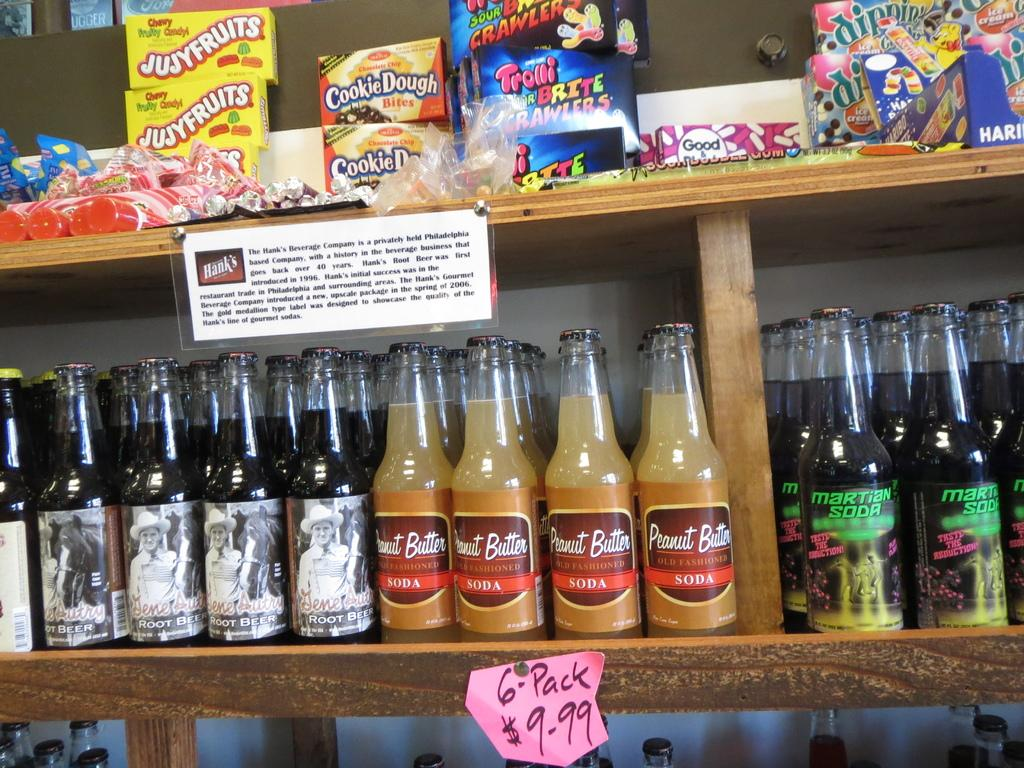What is the main object in the image? There is a rack in the image. What is placed on the rack? There are bottles arranged in a sequence manner on the rack, and there are candies at the top of the rack. Are there any additional items related to the rack? Yes, there is a price tag and a note in the image. What type of wool can be seen being squeezed in the image? There is no wool or any squeezing activity present in the image. What type of juice is being poured from a bottle in the image? There is no juice or any pouring activity present in the image. 